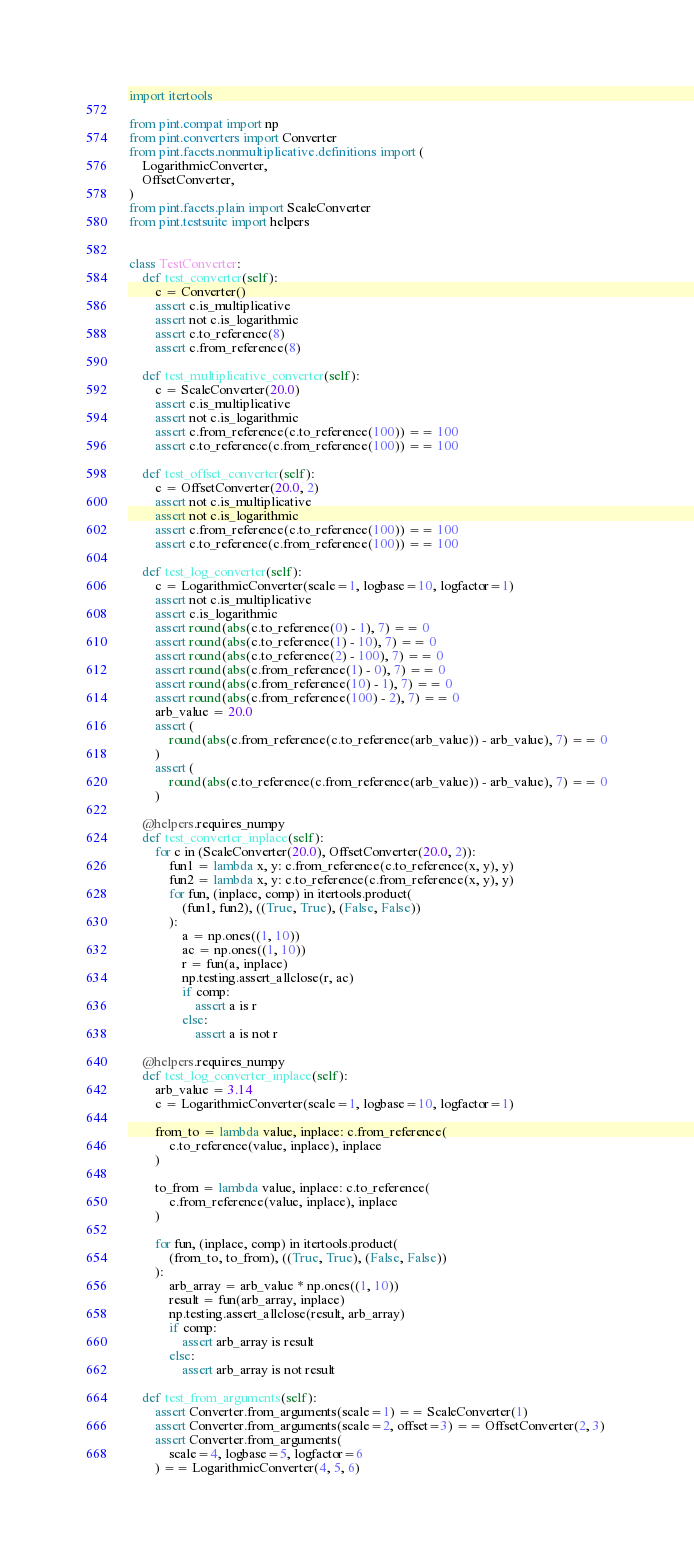<code> <loc_0><loc_0><loc_500><loc_500><_Python_>import itertools

from pint.compat import np
from pint.converters import Converter
from pint.facets.nonmultiplicative.definitions import (
    LogarithmicConverter,
    OffsetConverter,
)
from pint.facets.plain import ScaleConverter
from pint.testsuite import helpers


class TestConverter:
    def test_converter(self):
        c = Converter()
        assert c.is_multiplicative
        assert not c.is_logarithmic
        assert c.to_reference(8)
        assert c.from_reference(8)

    def test_multiplicative_converter(self):
        c = ScaleConverter(20.0)
        assert c.is_multiplicative
        assert not c.is_logarithmic
        assert c.from_reference(c.to_reference(100)) == 100
        assert c.to_reference(c.from_reference(100)) == 100

    def test_offset_converter(self):
        c = OffsetConverter(20.0, 2)
        assert not c.is_multiplicative
        assert not c.is_logarithmic
        assert c.from_reference(c.to_reference(100)) == 100
        assert c.to_reference(c.from_reference(100)) == 100

    def test_log_converter(self):
        c = LogarithmicConverter(scale=1, logbase=10, logfactor=1)
        assert not c.is_multiplicative
        assert c.is_logarithmic
        assert round(abs(c.to_reference(0) - 1), 7) == 0
        assert round(abs(c.to_reference(1) - 10), 7) == 0
        assert round(abs(c.to_reference(2) - 100), 7) == 0
        assert round(abs(c.from_reference(1) - 0), 7) == 0
        assert round(abs(c.from_reference(10) - 1), 7) == 0
        assert round(abs(c.from_reference(100) - 2), 7) == 0
        arb_value = 20.0
        assert (
            round(abs(c.from_reference(c.to_reference(arb_value)) - arb_value), 7) == 0
        )
        assert (
            round(abs(c.to_reference(c.from_reference(arb_value)) - arb_value), 7) == 0
        )

    @helpers.requires_numpy
    def test_converter_inplace(self):
        for c in (ScaleConverter(20.0), OffsetConverter(20.0, 2)):
            fun1 = lambda x, y: c.from_reference(c.to_reference(x, y), y)
            fun2 = lambda x, y: c.to_reference(c.from_reference(x, y), y)
            for fun, (inplace, comp) in itertools.product(
                (fun1, fun2), ((True, True), (False, False))
            ):
                a = np.ones((1, 10))
                ac = np.ones((1, 10))
                r = fun(a, inplace)
                np.testing.assert_allclose(r, ac)
                if comp:
                    assert a is r
                else:
                    assert a is not r

    @helpers.requires_numpy
    def test_log_converter_inplace(self):
        arb_value = 3.14
        c = LogarithmicConverter(scale=1, logbase=10, logfactor=1)

        from_to = lambda value, inplace: c.from_reference(
            c.to_reference(value, inplace), inplace
        )

        to_from = lambda value, inplace: c.to_reference(
            c.from_reference(value, inplace), inplace
        )

        for fun, (inplace, comp) in itertools.product(
            (from_to, to_from), ((True, True), (False, False))
        ):
            arb_array = arb_value * np.ones((1, 10))
            result = fun(arb_array, inplace)
            np.testing.assert_allclose(result, arb_array)
            if comp:
                assert arb_array is result
            else:
                assert arb_array is not result

    def test_from_arguments(self):
        assert Converter.from_arguments(scale=1) == ScaleConverter(1)
        assert Converter.from_arguments(scale=2, offset=3) == OffsetConverter(2, 3)
        assert Converter.from_arguments(
            scale=4, logbase=5, logfactor=6
        ) == LogarithmicConverter(4, 5, 6)
</code> 